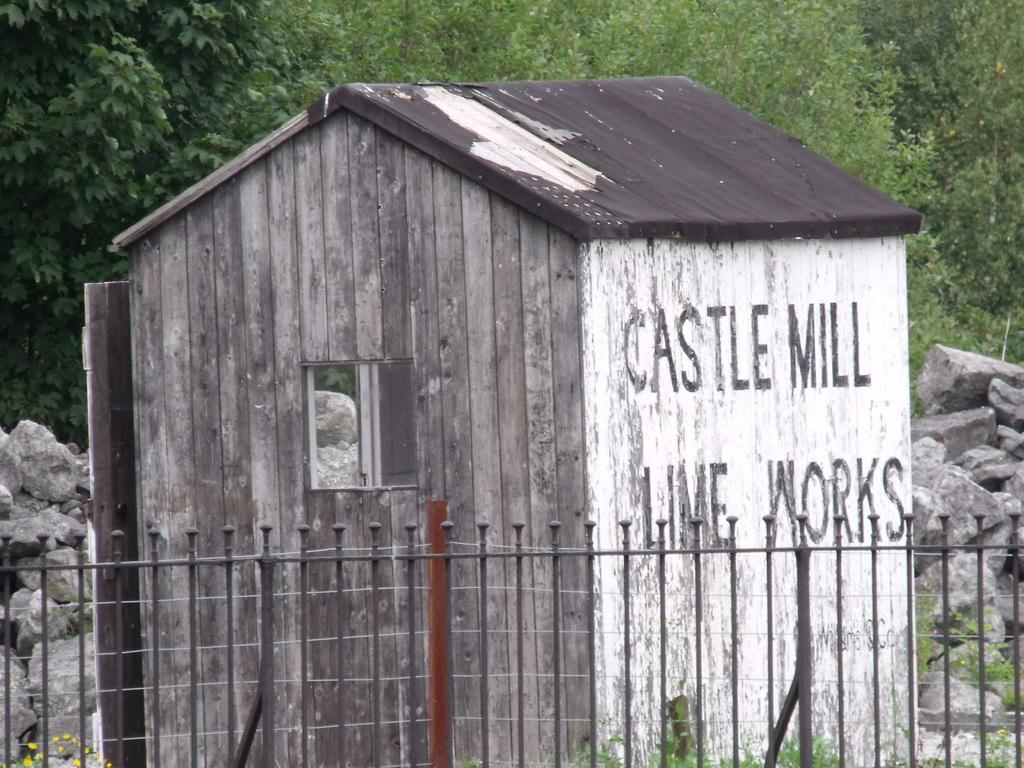Provide a one-sentence caption for the provided image. old wooden building labeled castle mill lime works behind a fence. 